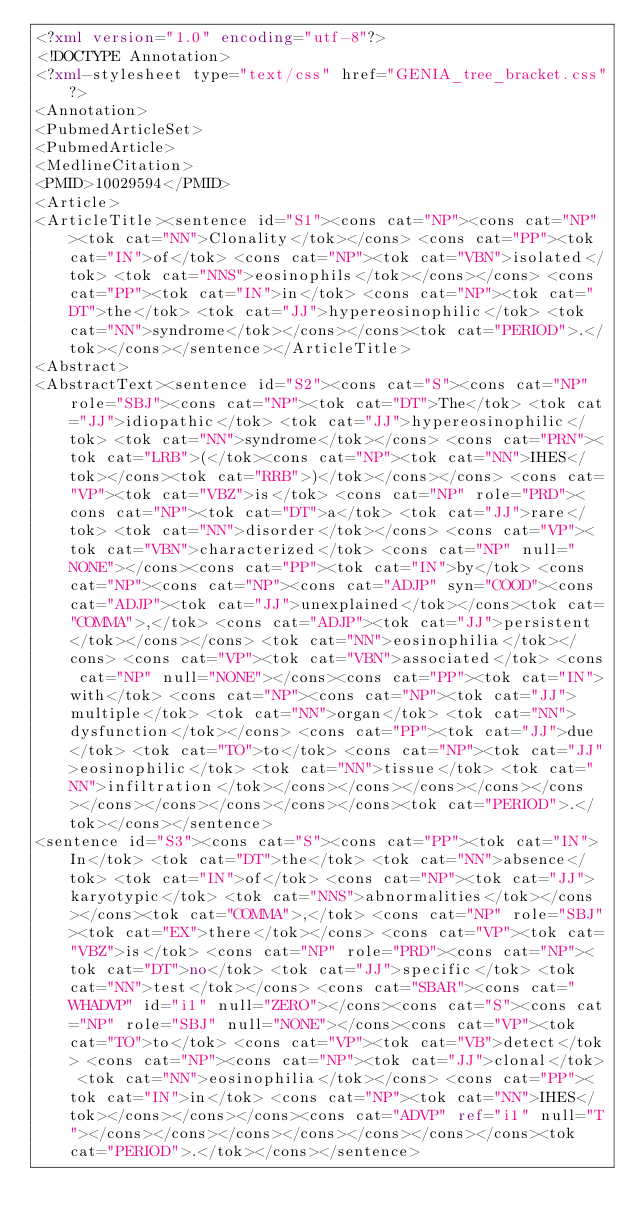<code> <loc_0><loc_0><loc_500><loc_500><_XML_><?xml version="1.0" encoding="utf-8"?>
<!DOCTYPE Annotation>
<?xml-stylesheet type="text/css" href="GENIA_tree_bracket.css"?>
<Annotation>
<PubmedArticleSet>
<PubmedArticle>
<MedlineCitation>
<PMID>10029594</PMID>
<Article>
<ArticleTitle><sentence id="S1"><cons cat="NP"><cons cat="NP"><tok cat="NN">Clonality</tok></cons> <cons cat="PP"><tok cat="IN">of</tok> <cons cat="NP"><tok cat="VBN">isolated</tok> <tok cat="NNS">eosinophils</tok></cons></cons> <cons cat="PP"><tok cat="IN">in</tok> <cons cat="NP"><tok cat="DT">the</tok> <tok cat="JJ">hypereosinophilic</tok> <tok cat="NN">syndrome</tok></cons></cons><tok cat="PERIOD">.</tok></cons></sentence></ArticleTitle>
<Abstract>
<AbstractText><sentence id="S2"><cons cat="S"><cons cat="NP" role="SBJ"><cons cat="NP"><tok cat="DT">The</tok> <tok cat="JJ">idiopathic</tok> <tok cat="JJ">hypereosinophilic</tok> <tok cat="NN">syndrome</tok></cons> <cons cat="PRN"><tok cat="LRB">(</tok><cons cat="NP"><tok cat="NN">IHES</tok></cons><tok cat="RRB">)</tok></cons></cons> <cons cat="VP"><tok cat="VBZ">is</tok> <cons cat="NP" role="PRD"><cons cat="NP"><tok cat="DT">a</tok> <tok cat="JJ">rare</tok> <tok cat="NN">disorder</tok></cons> <cons cat="VP"><tok cat="VBN">characterized</tok> <cons cat="NP" null="NONE"></cons><cons cat="PP"><tok cat="IN">by</tok> <cons cat="NP"><cons cat="NP"><cons cat="ADJP" syn="COOD"><cons cat="ADJP"><tok cat="JJ">unexplained</tok></cons><tok cat="COMMA">,</tok> <cons cat="ADJP"><tok cat="JJ">persistent</tok></cons></cons> <tok cat="NN">eosinophilia</tok></cons> <cons cat="VP"><tok cat="VBN">associated</tok> <cons cat="NP" null="NONE"></cons><cons cat="PP"><tok cat="IN">with</tok> <cons cat="NP"><cons cat="NP"><tok cat="JJ">multiple</tok> <tok cat="NN">organ</tok> <tok cat="NN">dysfunction</tok></cons> <cons cat="PP"><tok cat="JJ">due</tok> <tok cat="TO">to</tok> <cons cat="NP"><tok cat="JJ">eosinophilic</tok> <tok cat="NN">tissue</tok> <tok cat="NN">infiltration</tok></cons></cons></cons></cons></cons></cons></cons></cons></cons></cons><tok cat="PERIOD">.</tok></cons></sentence>
<sentence id="S3"><cons cat="S"><cons cat="PP"><tok cat="IN">In</tok> <tok cat="DT">the</tok> <tok cat="NN">absence</tok> <tok cat="IN">of</tok> <cons cat="NP"><tok cat="JJ">karyotypic</tok> <tok cat="NNS">abnormalities</tok></cons></cons><tok cat="COMMA">,</tok> <cons cat="NP" role="SBJ"><tok cat="EX">there</tok></cons> <cons cat="VP"><tok cat="VBZ">is</tok> <cons cat="NP" role="PRD"><cons cat="NP"><tok cat="DT">no</tok> <tok cat="JJ">specific</tok> <tok cat="NN">test</tok></cons> <cons cat="SBAR"><cons cat="WHADVP" id="i1" null="ZERO"></cons><cons cat="S"><cons cat="NP" role="SBJ" null="NONE"></cons><cons cat="VP"><tok cat="TO">to</tok> <cons cat="VP"><tok cat="VB">detect</tok> <cons cat="NP"><cons cat="NP"><tok cat="JJ">clonal</tok> <tok cat="NN">eosinophilia</tok></cons> <cons cat="PP"><tok cat="IN">in</tok> <cons cat="NP"><tok cat="NN">IHES</tok></cons></cons></cons><cons cat="ADVP" ref="i1" null="T"></cons></cons></cons></cons></cons></cons></cons><tok cat="PERIOD">.</tok></cons></sentence></code> 